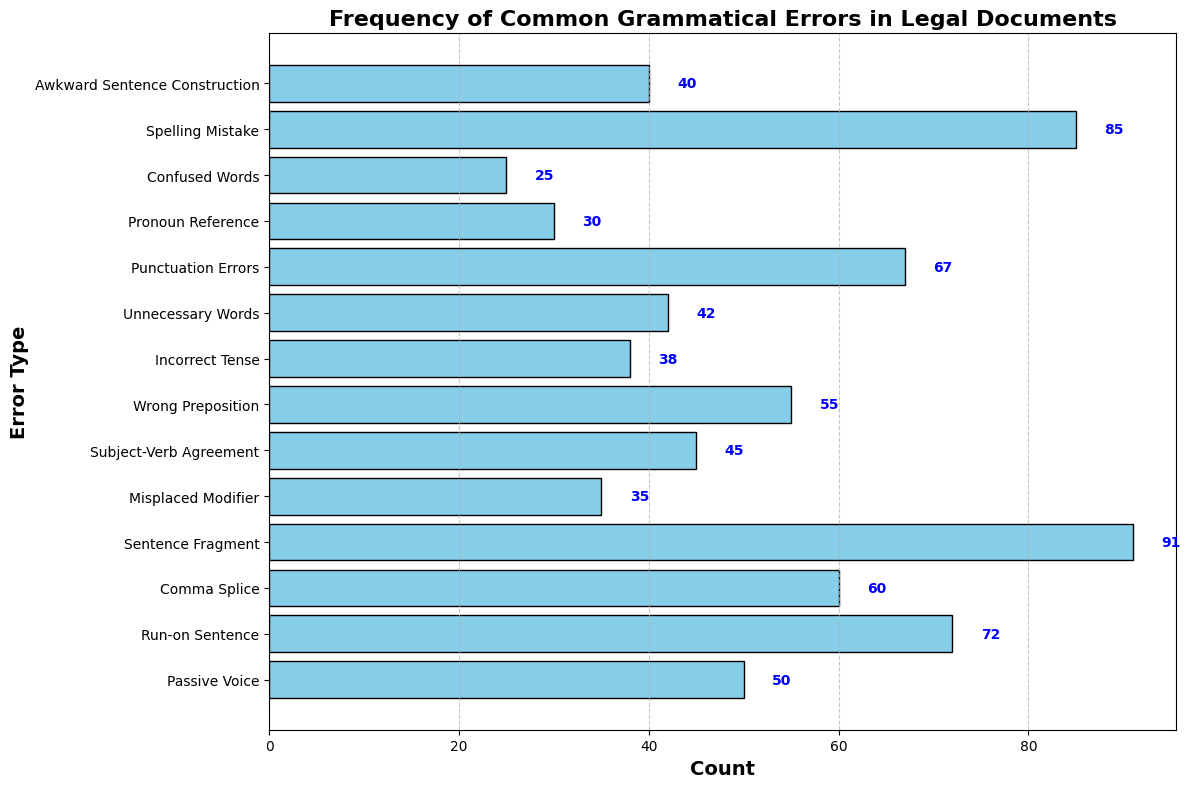Which error type has the highest frequency? By looking at the length of the bars, 'Sentence Fragment' has the highest frequency. The length of this bar is longer than the others.
Answer: Sentence Fragment How many more occurrences are there of 'Run-on Sentence' compared to 'Pronoun Reference'? To determine this, find the counts for both errors from the bars. 'Run-on Sentence' has 72 and 'Pronoun Reference' has 30. Subtract 30 from 72.
Answer: 42 What is the total frequency of 'Spelling Mistake' and 'Misplaced Modifier'? Add the counts for both errors. 'Spelling Mistake' has 85 and 'Misplaced Modifier' has 35. So, 85 + 35.
Answer: 120 Which grammatical error has fewer occurrences: 'Passive Voice' or 'Incorrect Tense'? Compare the lengths of the corresponding bars. 'Passive Voice' has 50 occurrences and 'Incorrect Tense' has 38 occurrences. 'Incorrect Tense' has fewer occurrences.
Answer: Incorrect Tense What is the difference in frequency between the most common and least common grammatical errors? Identify the most and least common errors from the bar lengths. 'Sentence Fragment' (91) is the most common and 'Confused Words' (25) is the least common. Subtract 25 from 91.
Answer: 66 Which error has a frequency closest to 40? Observe the length of the bars and their annotations. 'Awkward Sentence Construction' has a count of 40, which is the error closest to this value.
Answer: Awkward Sentence Construction How many errors have a frequency greater than 60? Count the number of bars with annotated values greater than 60. Errors with frequencies greater than 60 are 'Run-on Sentence' (72), 'Sentence Fragment' (91), 'Punctuation Errors' (67), and 'Spelling Mistake' (85).
Answer: 4 What is the approximate average frequency of 'Comma Splice', 'Punctuation Errors', and 'Subject-Verb Agreement'? Add the counts for these errors and divide by the number of errors. (60 + 67 + 45) / 3.
Answer: 57.33 Which error types have counts between 40 and 50? Observe the annotations and lengths of the bars. 'Passive Voice' (50), 'Subject-Verb Agreement' (45), and 'Unnecessary Words' (42) fall within this range.
Answer: Passive Voice, Subject-Verb Agreement, Unnecessary Words What is the combined frequency of 'Punctuation Errors' and 'Wrong Preposition'? Add the counts for 'Punctuation Errors' and 'Wrong Preposition'. 'Punctuation Errors' has 67 and 'Wrong Preposition' has 55. So, 67 + 55.
Answer: 122 